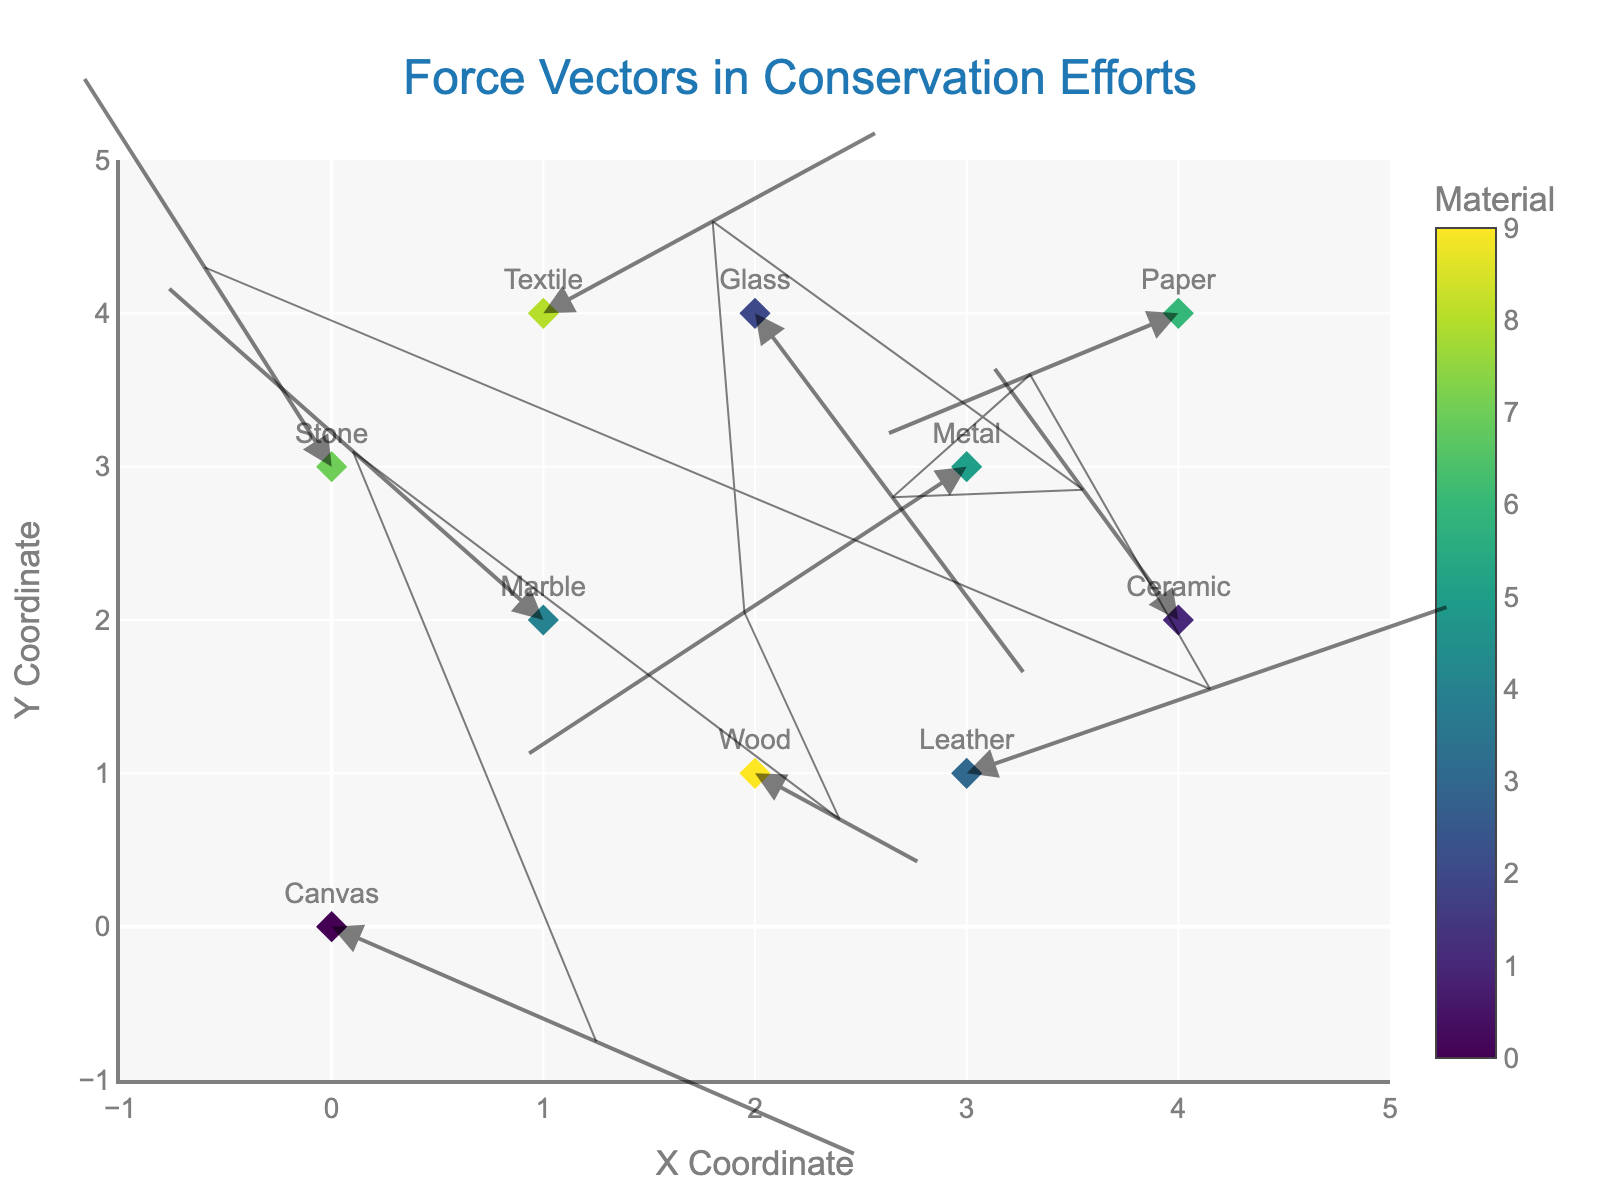How many different types of materials are used in the plot? The plot displays each material's name and corresponding force vector. By counting the distinct material names, we find there are 10 unique types.
Answer: 10 What's the material at coordinates (3, 1) and what is its force vector? Check the plot for the point positioned at (3, 1), then refer to its text and vector information. The point represents "Leather" with a force vector (2.3, 1.1).
Answer: Leather and (2.3, 1.1) Which material experiences the strongest force vector and under what environmental condition? To determine the strongest force vector, calculate the vector magnitudes using the formula sqrt(u^2 + v^2) for each material. "Glass" under "Indoor" conditions (magnitude = sqrt(1.3^2 + (-2.4)^2) = 2.7) experiences the strongest force.
Answer: Glass under Indoor How many materials are subject to negative x-component forces? Identify the vectors with negative x-components (u values) by examining the arrows pointing left. There are forces for "Marble," "Metal," "Ceramic," and "Paper," totaling 4 materials.
Answer: 4 Which two materials have force vectors with both positive components? Identify which arrows point right and upward. The positive x and y components belong to "Textile" and "Leather."
Answer: Textile and Leather Which material in a coastal environment is represented, and what is its force vector's direction? Find the arrow with the label "Coastal". "Metal" is the material, and its force vector (-2.1, -1.9) indicates southwest direction (down-left).
Answer: Metal and southwest Are there any materials in a humid environment exerting a negative y-component force? Check for "Humid" labeled material to see if the y-component of its vector is negative. The "Canvas" material fits this criterion with a vector (2.5, -1.5).
Answer: Yes Which material in a high altitude environment shows a positive y-component force and what are its coordinates? Locate the "High Altitude" label. "Stone" at coordinates (0, 3) has a positive y-component force of 2.6.
Answer: Stone and (0, 3) If you wanted to balance the forces on 'Wood' by applying an opposite force vector, what would the new force vector be? Note the current vector for "Wood" is (0.8, -0.6). To balance this, the new force should be the inverse: (-0.8, 0.6).
Answer: (-0.8, 0.6) 